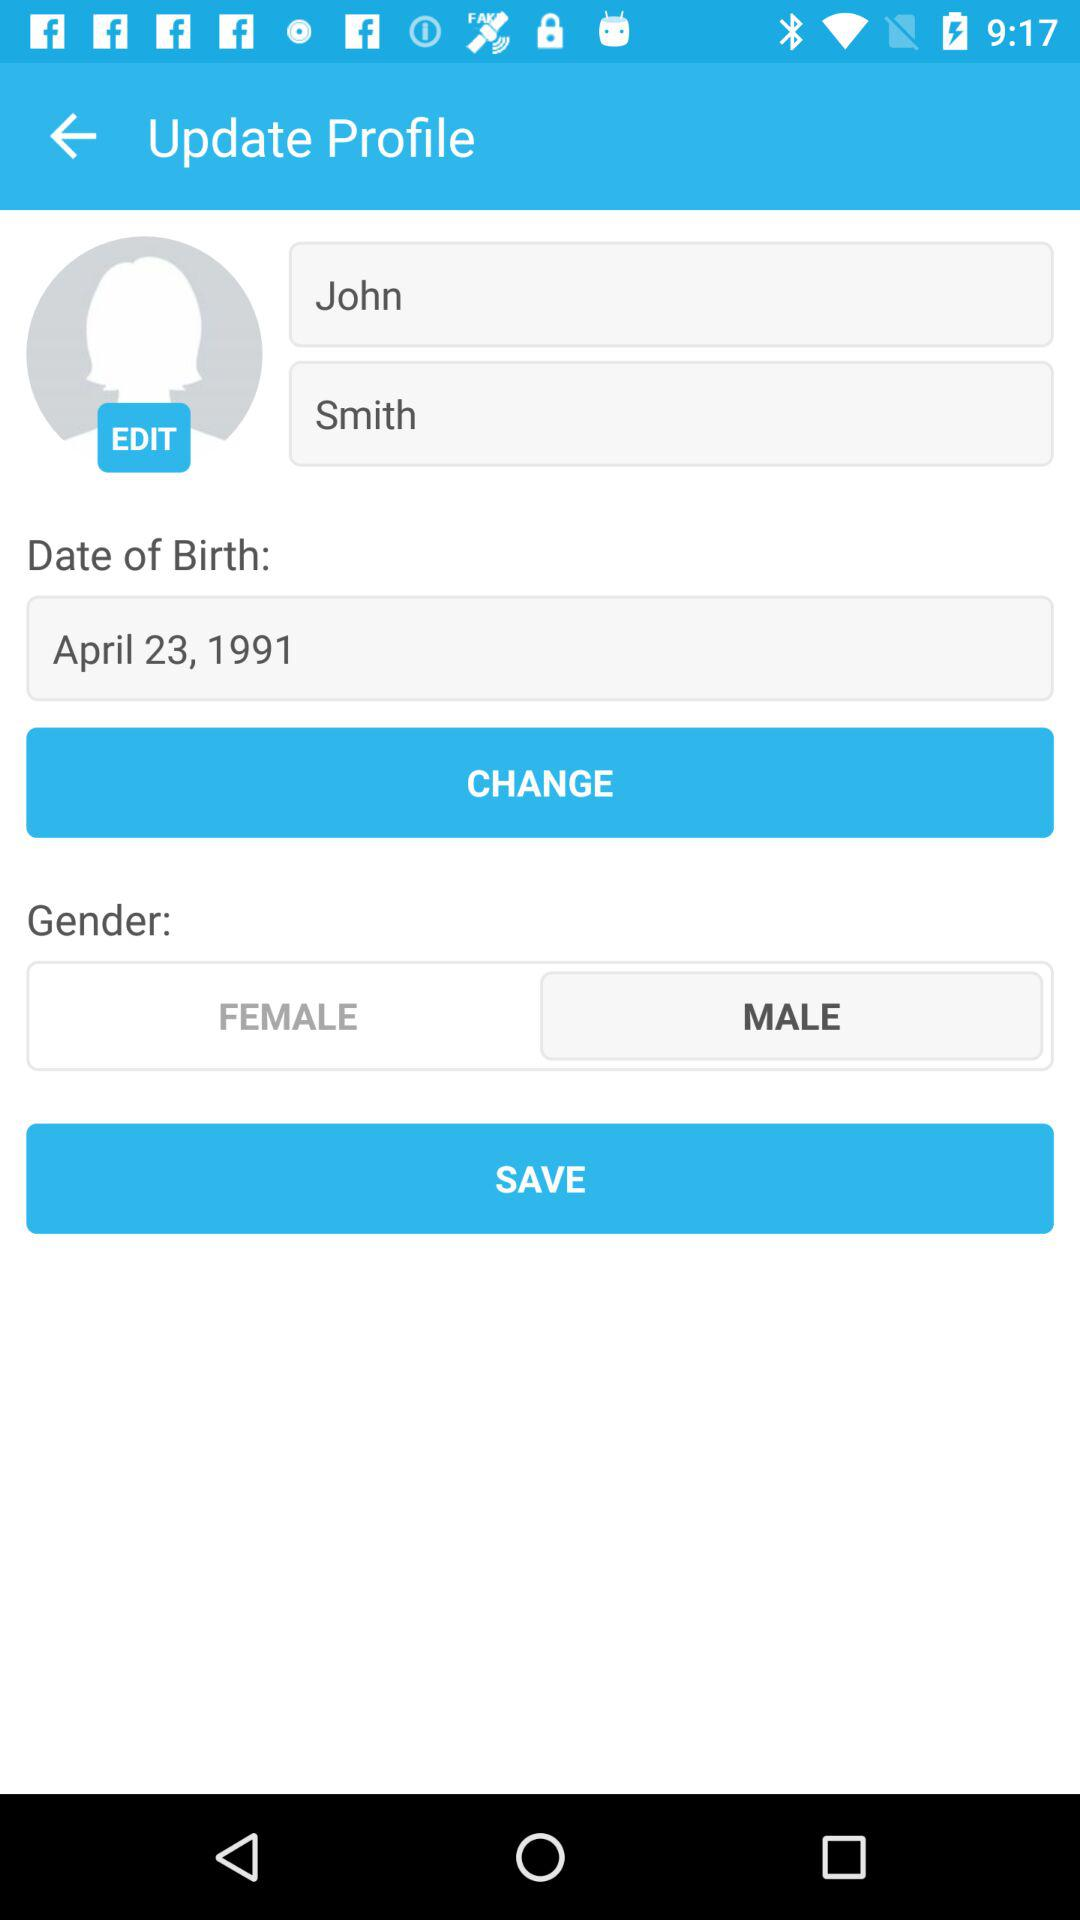What is the date of birth? The date of birth is April 23, 1991. 